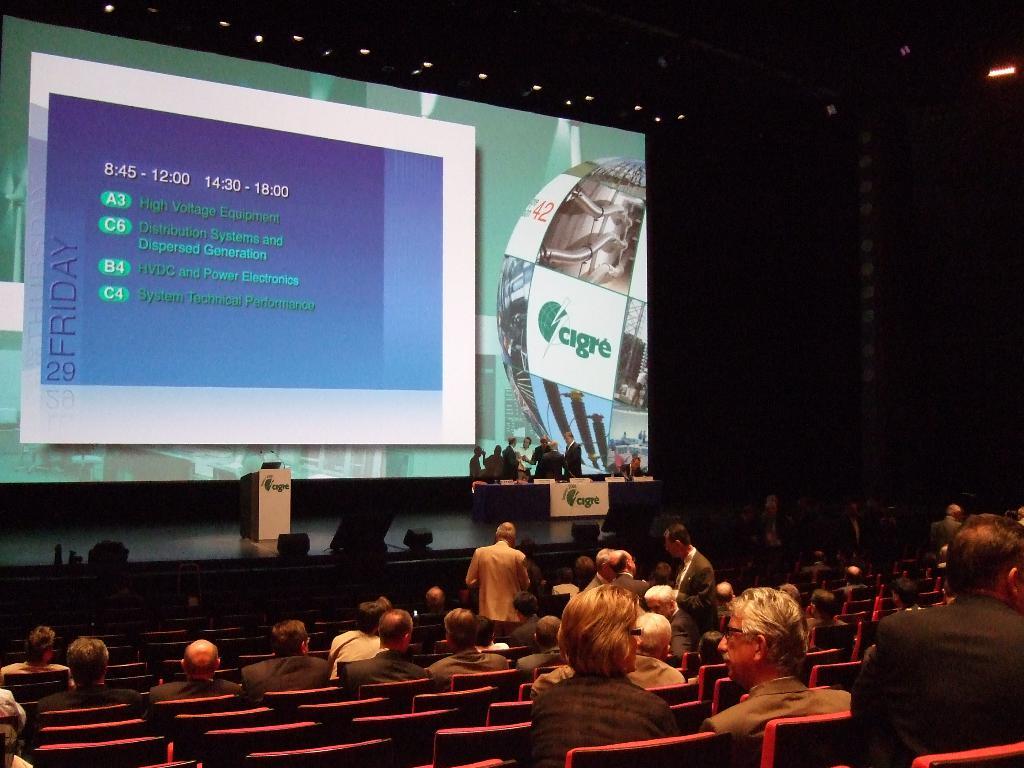What day of the week is on the screen?
Offer a terse response. Friday. What is the first time frame listed?
Give a very brief answer. 8:45. 